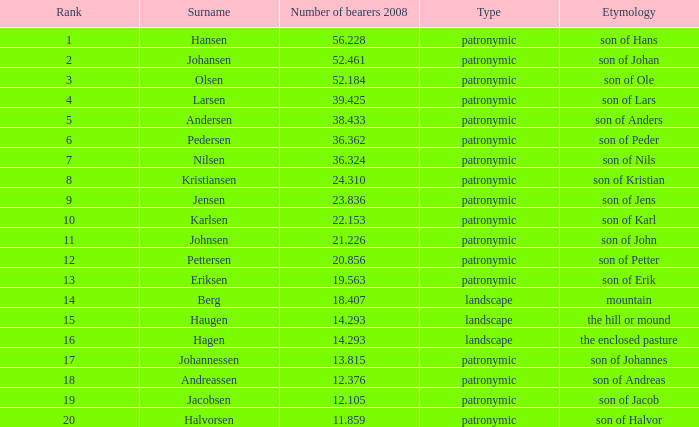What is Highest Number of Bearers 2008, when Surname is Jacobsen? 12.105. 